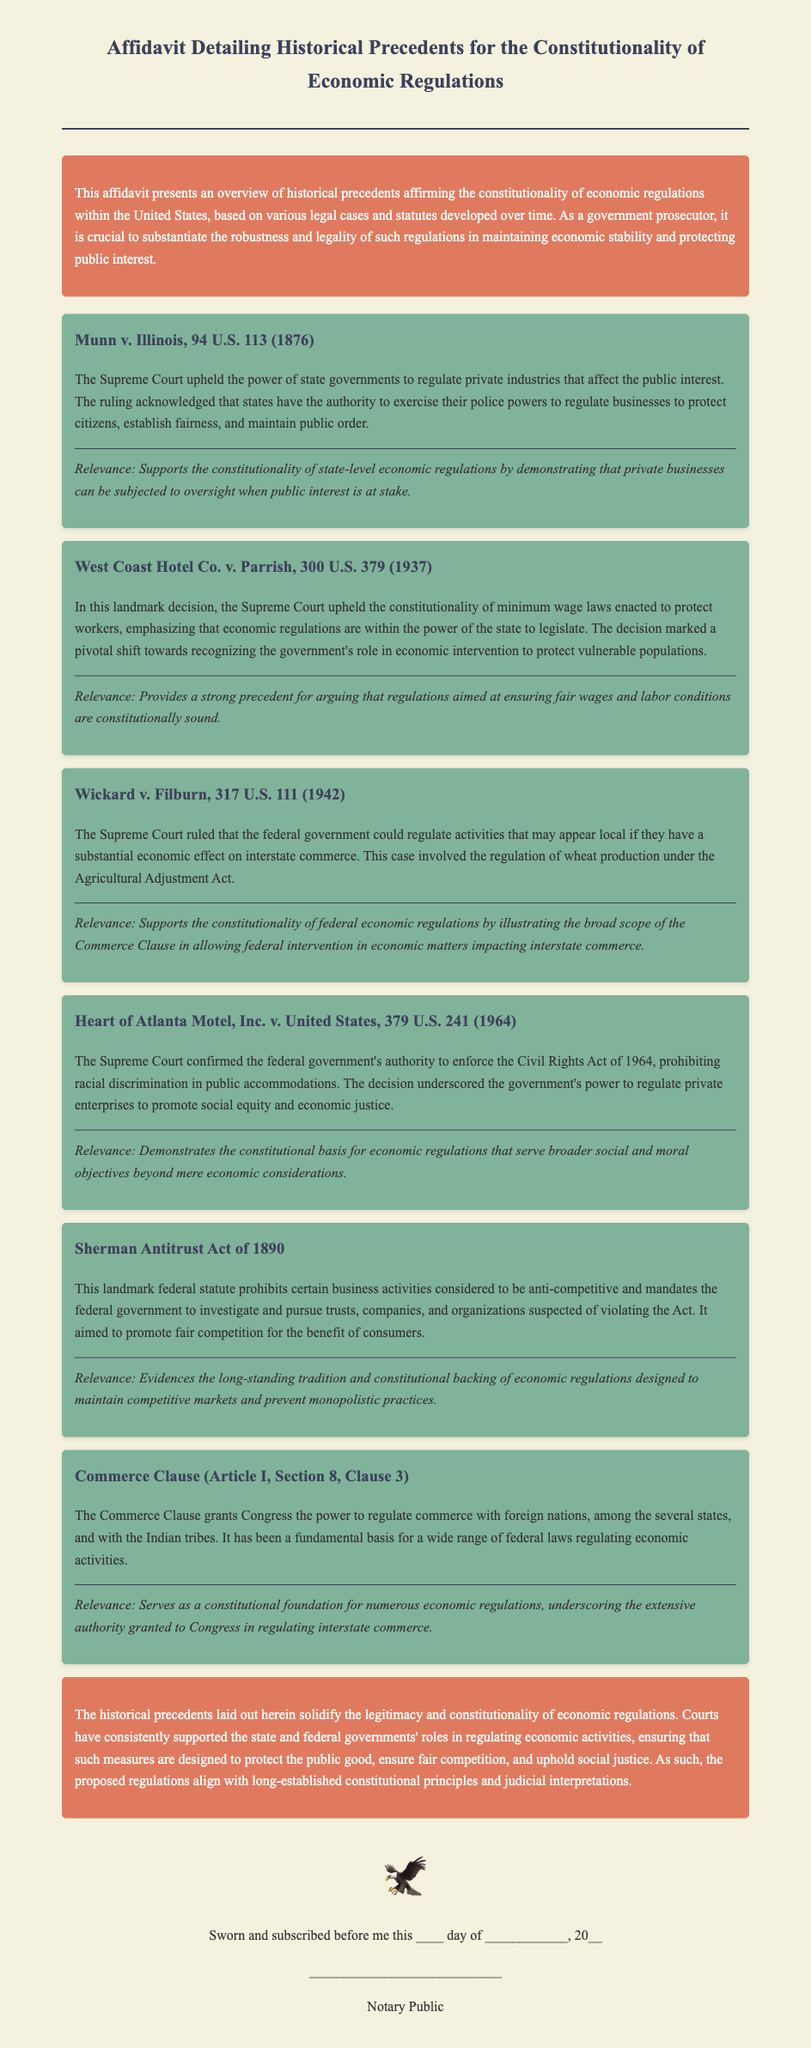What is the title of the document? The title of the document is located in the header section, which indicates its main subject.
Answer: Affidavit Detailing Historical Precedents for the Constitutionality of Economic Regulations What year was Munn v. Illinois decided? The decision date of Munn v. Illinois is found in the citation within the document.
Answer: 1876 What is the relevance of Wickard v. Filburn? The relevance section provides insight into the importance of the case regarding economic regulations at the federal level.
Answer: Supports the constitutionality of federal economic regulations What landmark federal statute is mentioned in the affidavit? The name of the federal statute can be found under the section discussing historical precedents for economic regulations.
Answer: Sherman Antitrust Act of 1890 What does the Commerce Clause grant Congress the power to do? The document clearly outlines the authority granted to Congress according to the Constitution.
Answer: Regulate commerce Which case upheld the constitutionality of minimum wage laws? The document highlights landmark decisions that affirm certain regulations, including which case specifically addressed minimum wage laws.
Answer: West Coast Hotel Co. v. Parrish What overarching theme does the conclusion of the affidavit emphasize? The conclusion summarizes the main argument presented throughout the document regarding historical precedents.
Answer: Legitimacy and constitutionality of economic regulations 